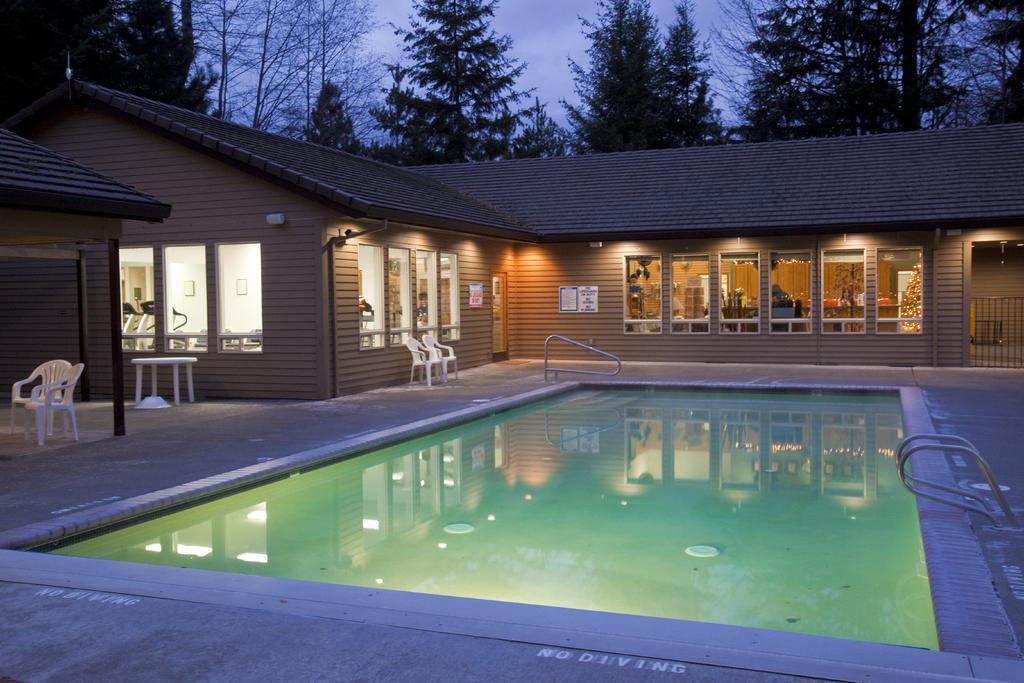In one or two sentences, can you explain what this image depicts? In front of the image there is a swimming pool, on the either side of the swimming pool there are metal rods, around the swimming pool there is a wooden house with glass windows, in front of the wooden house there are tables and chairs, on the house there are pipes, cameras and metal rods, through the glass windows we can see there are some people in the house and some objects, on the house there are posters on the walls and there are lumps, behind the house there are trees, on the right side of the image there is a metal rod fence. 